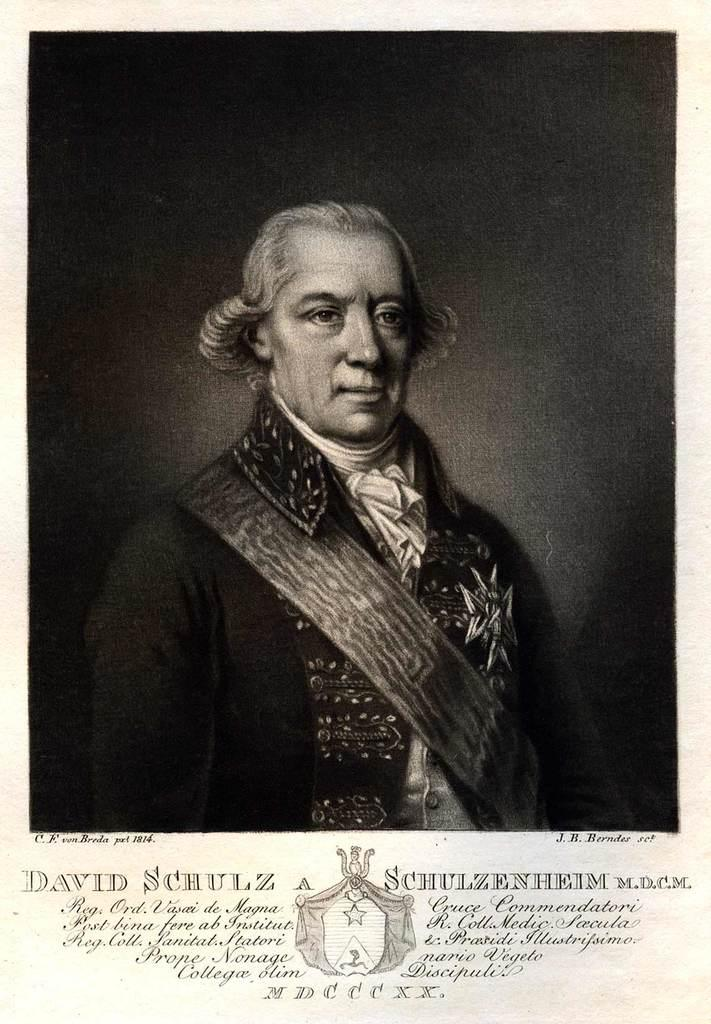Who or what is present in the image? There is a person in the image. What else can be seen in the image besides the person? There is some text in the image. What type of cork can be seen in the image? There is no cork present in the image. Is there a drum being played in the image? There is no drum or indication of music being played in the image. 